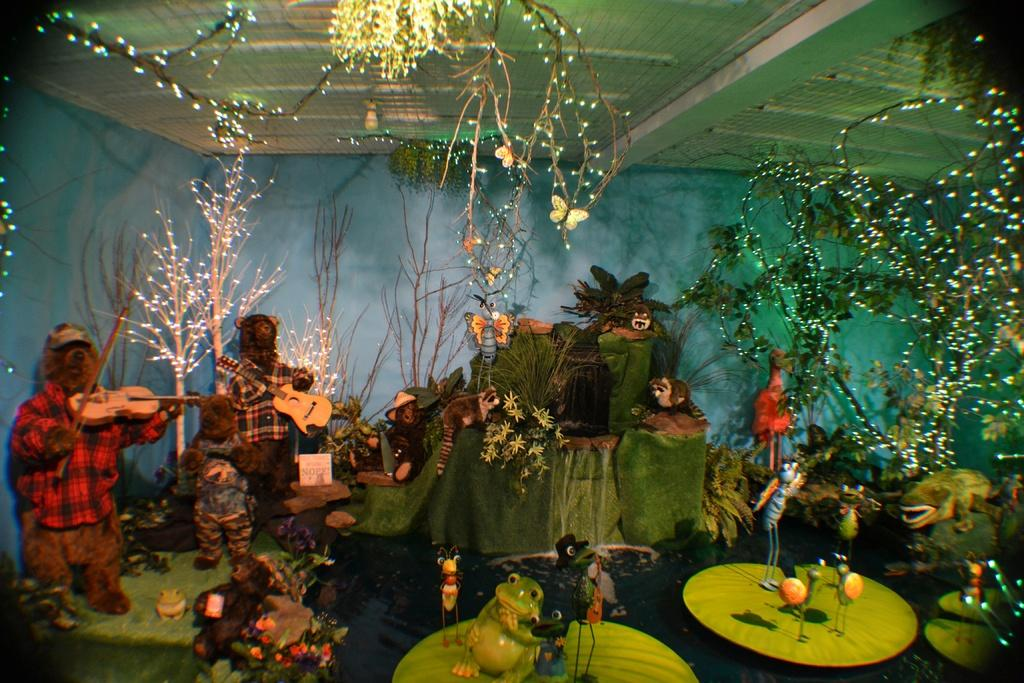What type of furniture is present in the image? There are tables in the image. What else can be seen on the tables? Various types of toys are present in the image. What part of a building can be seen in the image? There is a roof visible in the image. How much income does the frog in the image generate? There is no frog present in the image, so it is not possible to determine its income. 